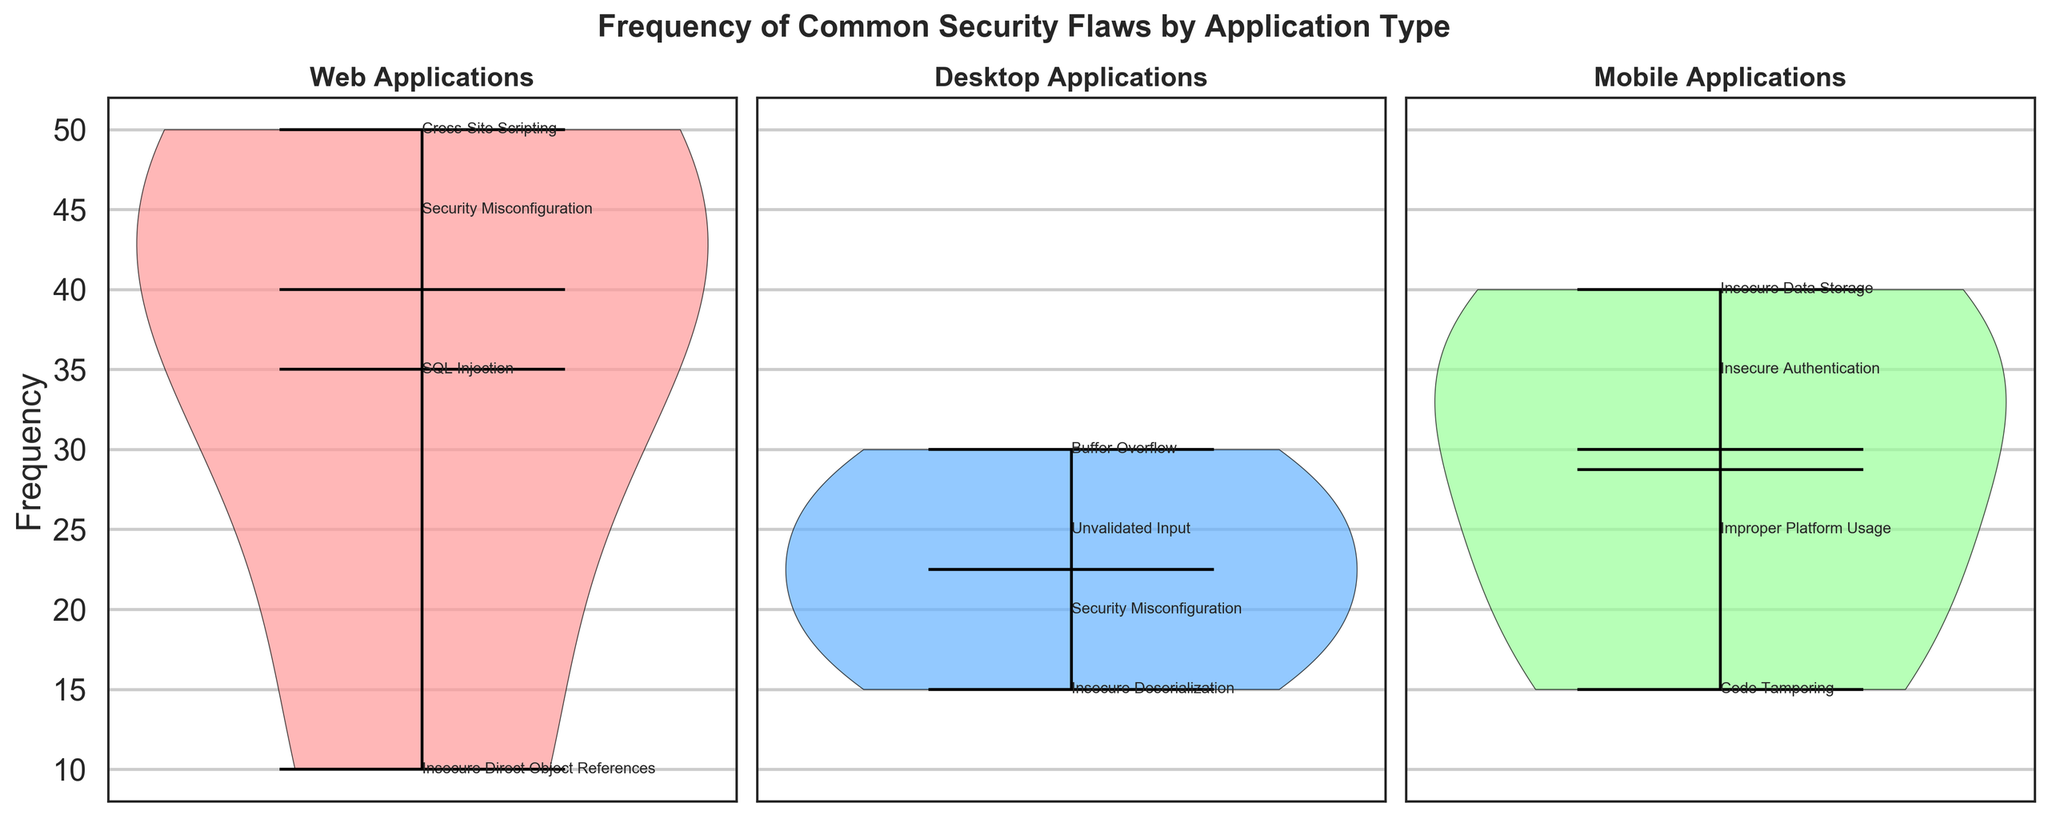What is the title of the figure? The title is usually placed at the top of the figure, and it summarizes the content of the figure. Here, the title "Frequency of Common Security Flaws by Application Type" is displayed at the top, indicating that the figure shows the frequency of various security flaws categorized by application type.
Answer: Frequency of Common Security Flaws by Application Type How many application types are compared in the figure? The figure uses three subplots, each representing a different application type. The titles of the subplots state the application types: Web, Desktop, and Mobile.
Answer: 3 Which security flaw in web applications has the highest frequency? By observing the frequencies labeled next to each security flaw in the 'Web Applications' subplot, Cross-Site Scripting has the highest frequency of 50.
Answer: Cross-Site Scripting What is the range of frequencies for security flaws in desktop applications? The range is calculated by identifying the minimum and maximum frequencies in the 'Desktop Applications' subplot. The minimum frequency is 15 (Insecure Deserialization), and the maximum frequency is 30 (Buffer Overflow). Therefore, the range is 30 - 15 = 15.
Answer: 15 Compare the median frequencies of security flaws in web and mobile applications. Which one is higher? The median frequency is indicated by the horizontal line within each violin plot. By comparing the lines, the web applications' median appears higher than mobile applications.
Answer: Web applications How does the security misconfiguration flaw frequency for desktop applications compare to mobile applications? By comparing the labeled frequencies, the frequency of security misconfiguration in desktop applications is 20, while on mobile applications, it is not listed, indicating 0. Hence, desktop applications have higher frequencies.
Answer: Higher in desktop What colors are used to represent the different application types in the subplots? The colors can be discerned by observing the violin plots and their body colors. Web applications use a light pink/red, desktop applications use light blue, and mobile applications use a light green color.
Answer: Light pink/red (Web), Light blue (Desktop), Light green (Mobile) Which security flaw in mobile applications has the lowest frequency? By reviewing the frequencies labeled in the 'Mobile Applications' subplot, Code Tampering has the lowest frequency of 15.
Answer: Code Tampering 